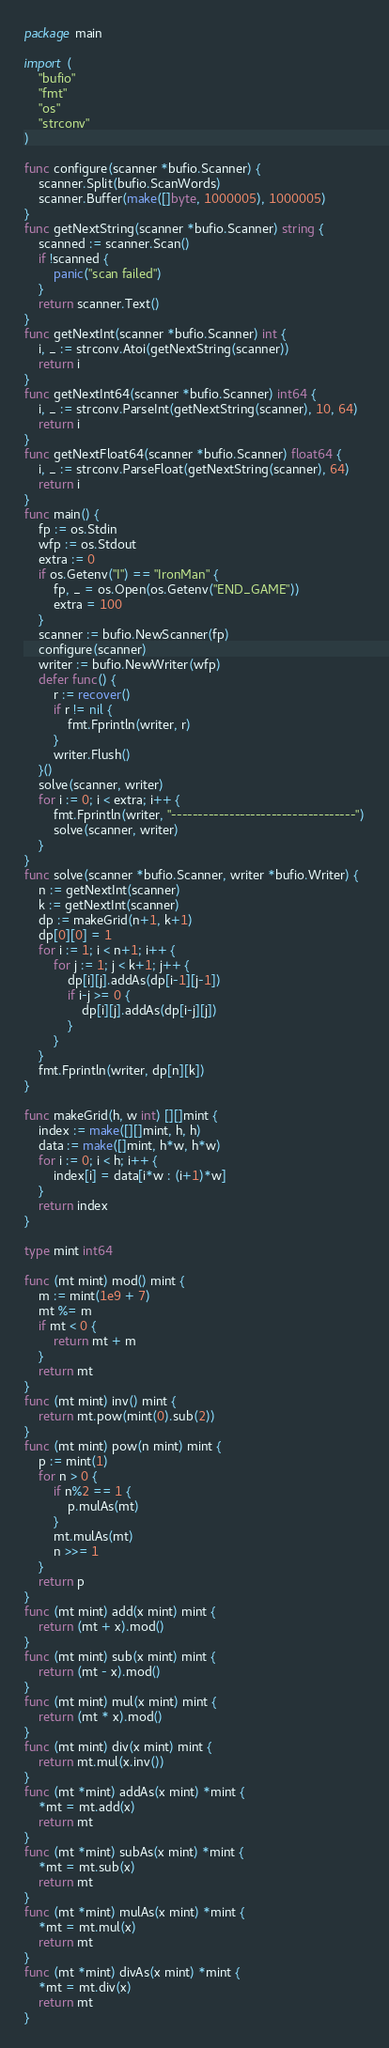Convert code to text. <code><loc_0><loc_0><loc_500><loc_500><_Go_>package main

import (
	"bufio"
	"fmt"
	"os"
	"strconv"
)

func configure(scanner *bufio.Scanner) {
	scanner.Split(bufio.ScanWords)
	scanner.Buffer(make([]byte, 1000005), 1000005)
}
func getNextString(scanner *bufio.Scanner) string {
	scanned := scanner.Scan()
	if !scanned {
		panic("scan failed")
	}
	return scanner.Text()
}
func getNextInt(scanner *bufio.Scanner) int {
	i, _ := strconv.Atoi(getNextString(scanner))
	return i
}
func getNextInt64(scanner *bufio.Scanner) int64 {
	i, _ := strconv.ParseInt(getNextString(scanner), 10, 64)
	return i
}
func getNextFloat64(scanner *bufio.Scanner) float64 {
	i, _ := strconv.ParseFloat(getNextString(scanner), 64)
	return i
}
func main() {
	fp := os.Stdin
	wfp := os.Stdout
	extra := 0
	if os.Getenv("I") == "IronMan" {
		fp, _ = os.Open(os.Getenv("END_GAME"))
		extra = 100
	}
	scanner := bufio.NewScanner(fp)
	configure(scanner)
	writer := bufio.NewWriter(wfp)
	defer func() {
		r := recover()
		if r != nil {
			fmt.Fprintln(writer, r)
		}
		writer.Flush()
	}()
	solve(scanner, writer)
	for i := 0; i < extra; i++ {
		fmt.Fprintln(writer, "-----------------------------------")
		solve(scanner, writer)
	}
}
func solve(scanner *bufio.Scanner, writer *bufio.Writer) {
	n := getNextInt(scanner)
	k := getNextInt(scanner)
	dp := makeGrid(n+1, k+1)
	dp[0][0] = 1
	for i := 1; i < n+1; i++ {
		for j := 1; j < k+1; j++ {
			dp[i][j].addAs(dp[i-1][j-1])
			if i-j >= 0 {
				dp[i][j].addAs(dp[i-j][j])
			}
		}
	}
	fmt.Fprintln(writer, dp[n][k])
}

func makeGrid(h, w int) [][]mint {
	index := make([][]mint, h, h)
	data := make([]mint, h*w, h*w)
	for i := 0; i < h; i++ {
		index[i] = data[i*w : (i+1)*w]
	}
	return index
}

type mint int64

func (mt mint) mod() mint {
	m := mint(1e9 + 7)
	mt %= m
	if mt < 0 {
		return mt + m
	}
	return mt
}
func (mt mint) inv() mint {
	return mt.pow(mint(0).sub(2))
}
func (mt mint) pow(n mint) mint {
	p := mint(1)
	for n > 0 {
		if n%2 == 1 {
			p.mulAs(mt)
		}
		mt.mulAs(mt)
		n >>= 1
	}
	return p
}
func (mt mint) add(x mint) mint {
	return (mt + x).mod()
}
func (mt mint) sub(x mint) mint {
	return (mt - x).mod()
}
func (mt mint) mul(x mint) mint {
	return (mt * x).mod()
}
func (mt mint) div(x mint) mint {
	return mt.mul(x.inv())
}
func (mt *mint) addAs(x mint) *mint {
	*mt = mt.add(x)
	return mt
}
func (mt *mint) subAs(x mint) *mint {
	*mt = mt.sub(x)
	return mt
}
func (mt *mint) mulAs(x mint) *mint {
	*mt = mt.mul(x)
	return mt
}
func (mt *mint) divAs(x mint) *mint {
	*mt = mt.div(x)
	return mt
}

</code> 